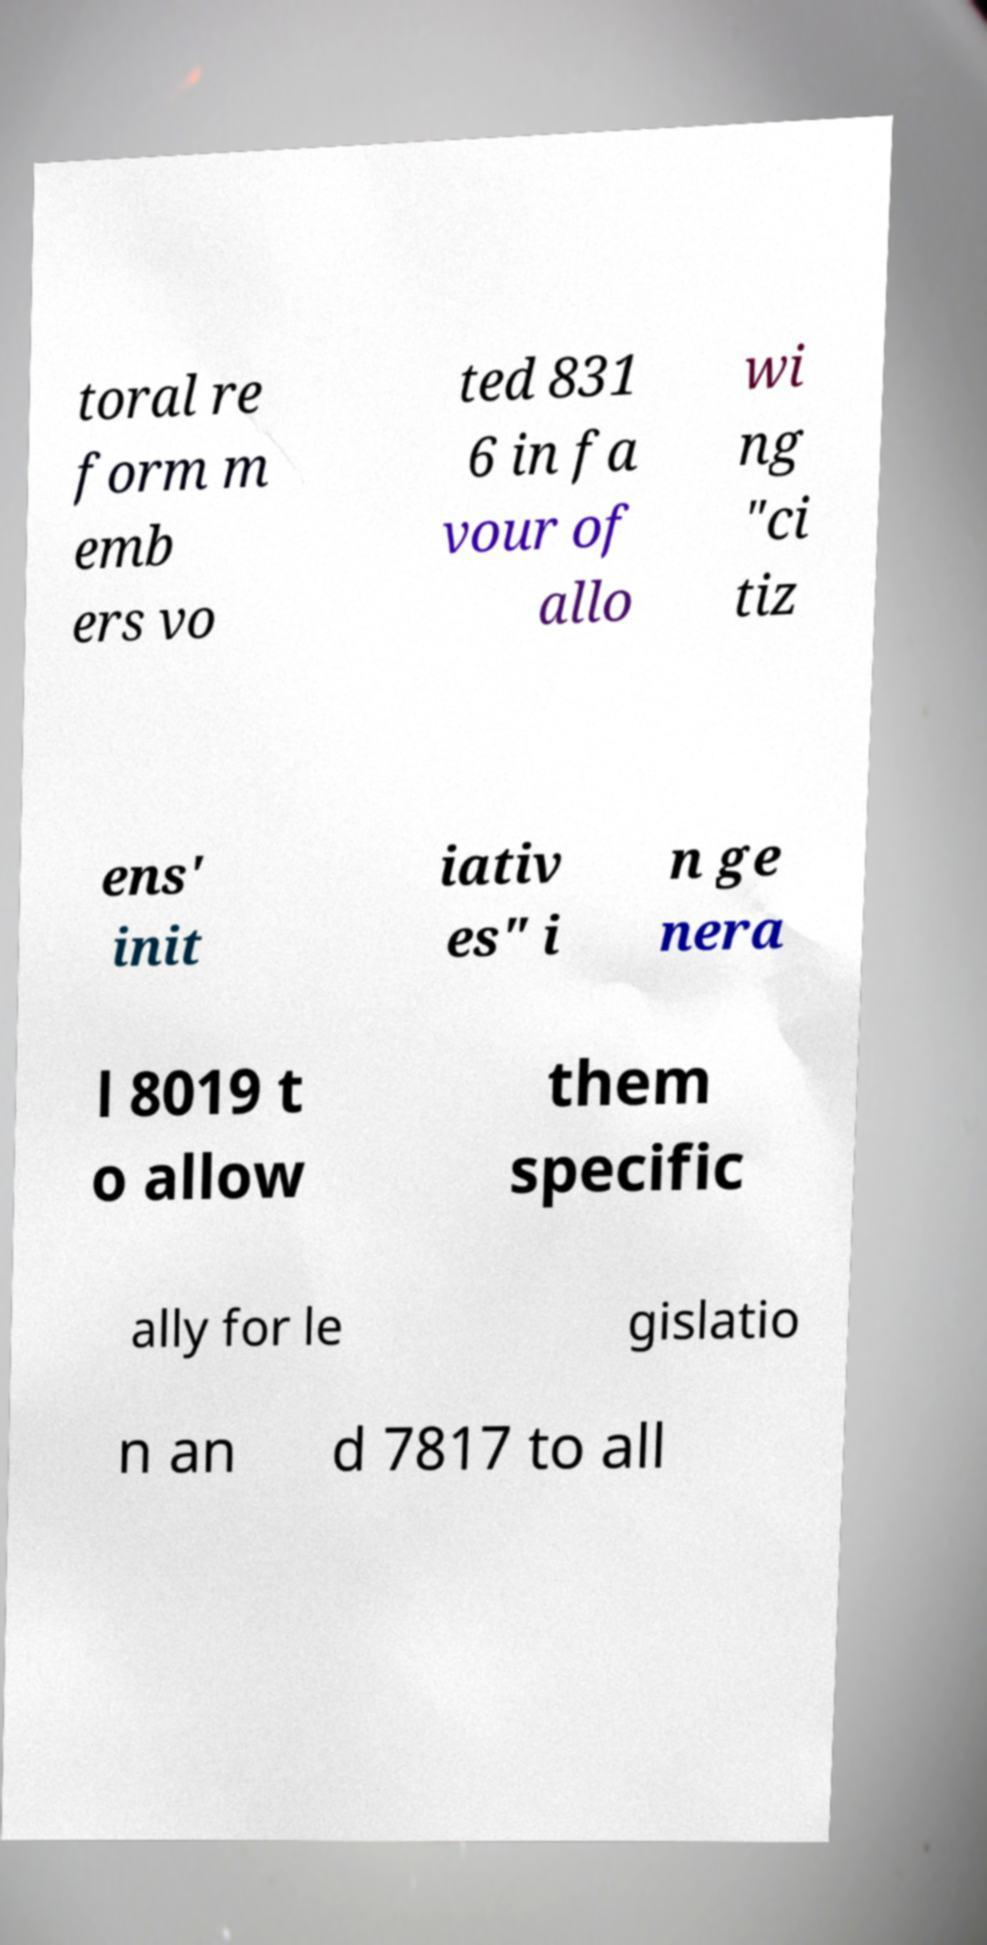Could you assist in decoding the text presented in this image and type it out clearly? toral re form m emb ers vo ted 831 6 in fa vour of allo wi ng "ci tiz ens' init iativ es" i n ge nera l 8019 t o allow them specific ally for le gislatio n an d 7817 to all 